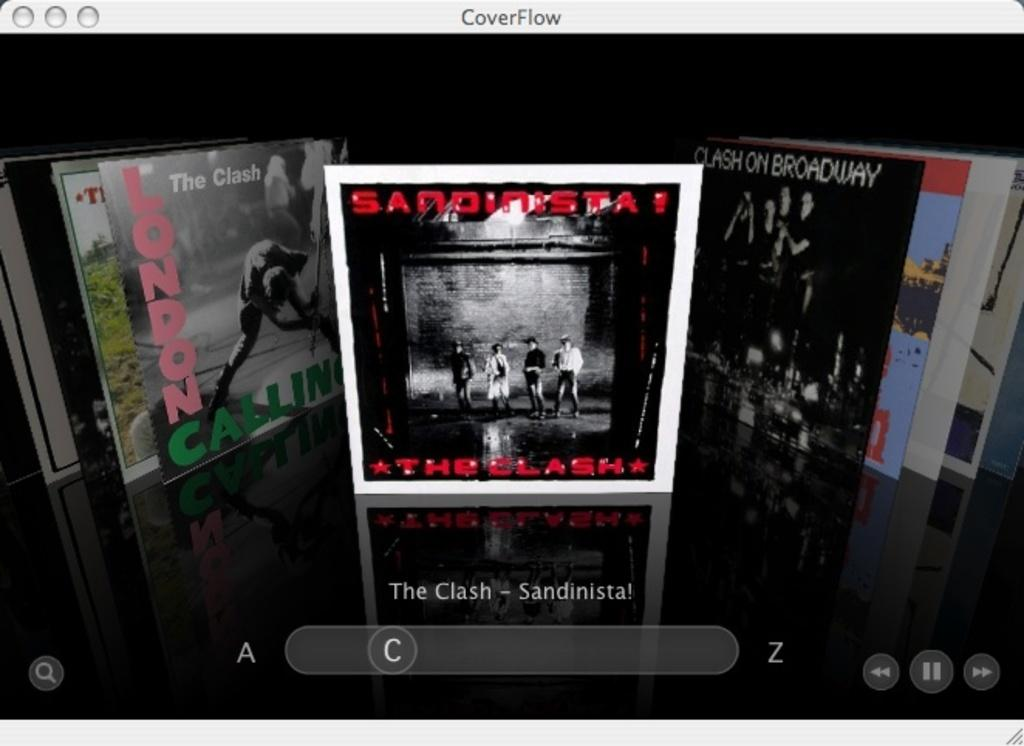<image>
Offer a succinct explanation of the picture presented. The album art for an album by The Clash is shown. 